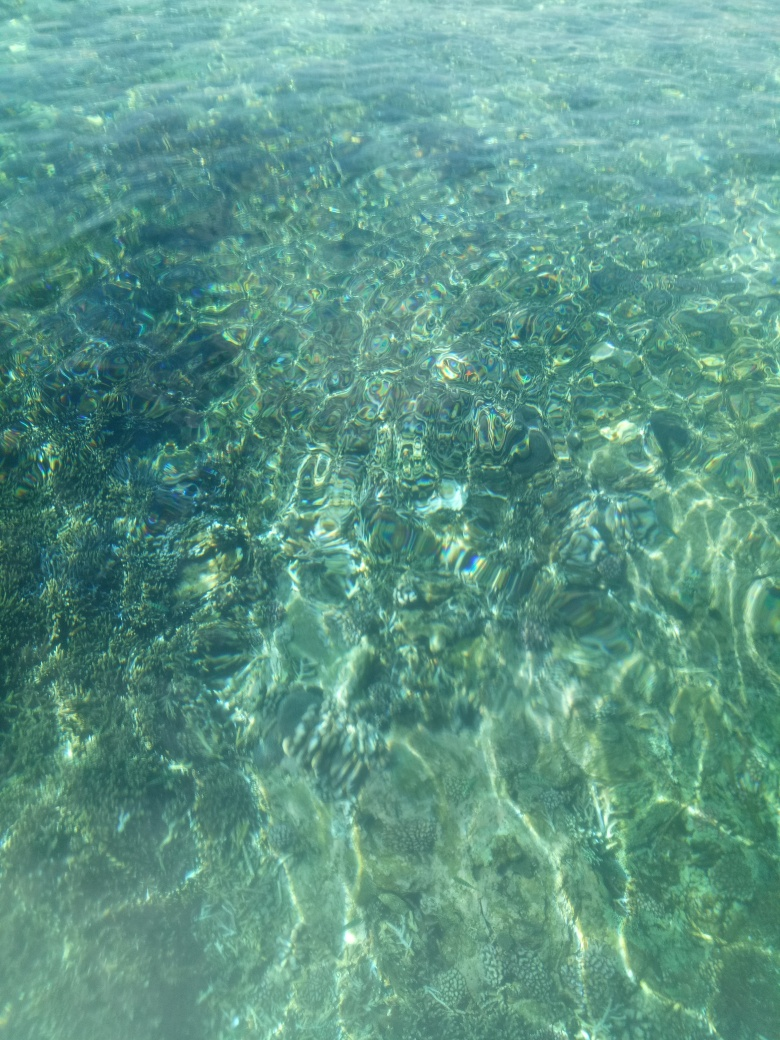What time of day does this photo seem to have been taken? The brightness and the angle of the light rays penetrating the water suggest it is midday, when the sun is at its highest point, allowing for maximum light and minimal shadow over the water. 